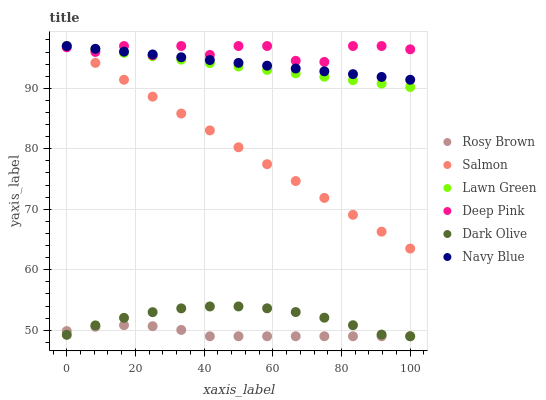Does Rosy Brown have the minimum area under the curve?
Answer yes or no. Yes. Does Deep Pink have the maximum area under the curve?
Answer yes or no. Yes. Does Navy Blue have the minimum area under the curve?
Answer yes or no. No. Does Navy Blue have the maximum area under the curve?
Answer yes or no. No. Is Salmon the smoothest?
Answer yes or no. Yes. Is Deep Pink the roughest?
Answer yes or no. Yes. Is Rosy Brown the smoothest?
Answer yes or no. No. Is Rosy Brown the roughest?
Answer yes or no. No. Does Rosy Brown have the lowest value?
Answer yes or no. Yes. Does Navy Blue have the lowest value?
Answer yes or no. No. Does Deep Pink have the highest value?
Answer yes or no. Yes. Does Rosy Brown have the highest value?
Answer yes or no. No. Is Rosy Brown less than Deep Pink?
Answer yes or no. Yes. Is Deep Pink greater than Rosy Brown?
Answer yes or no. Yes. Does Salmon intersect Deep Pink?
Answer yes or no. Yes. Is Salmon less than Deep Pink?
Answer yes or no. No. Is Salmon greater than Deep Pink?
Answer yes or no. No. Does Rosy Brown intersect Deep Pink?
Answer yes or no. No. 